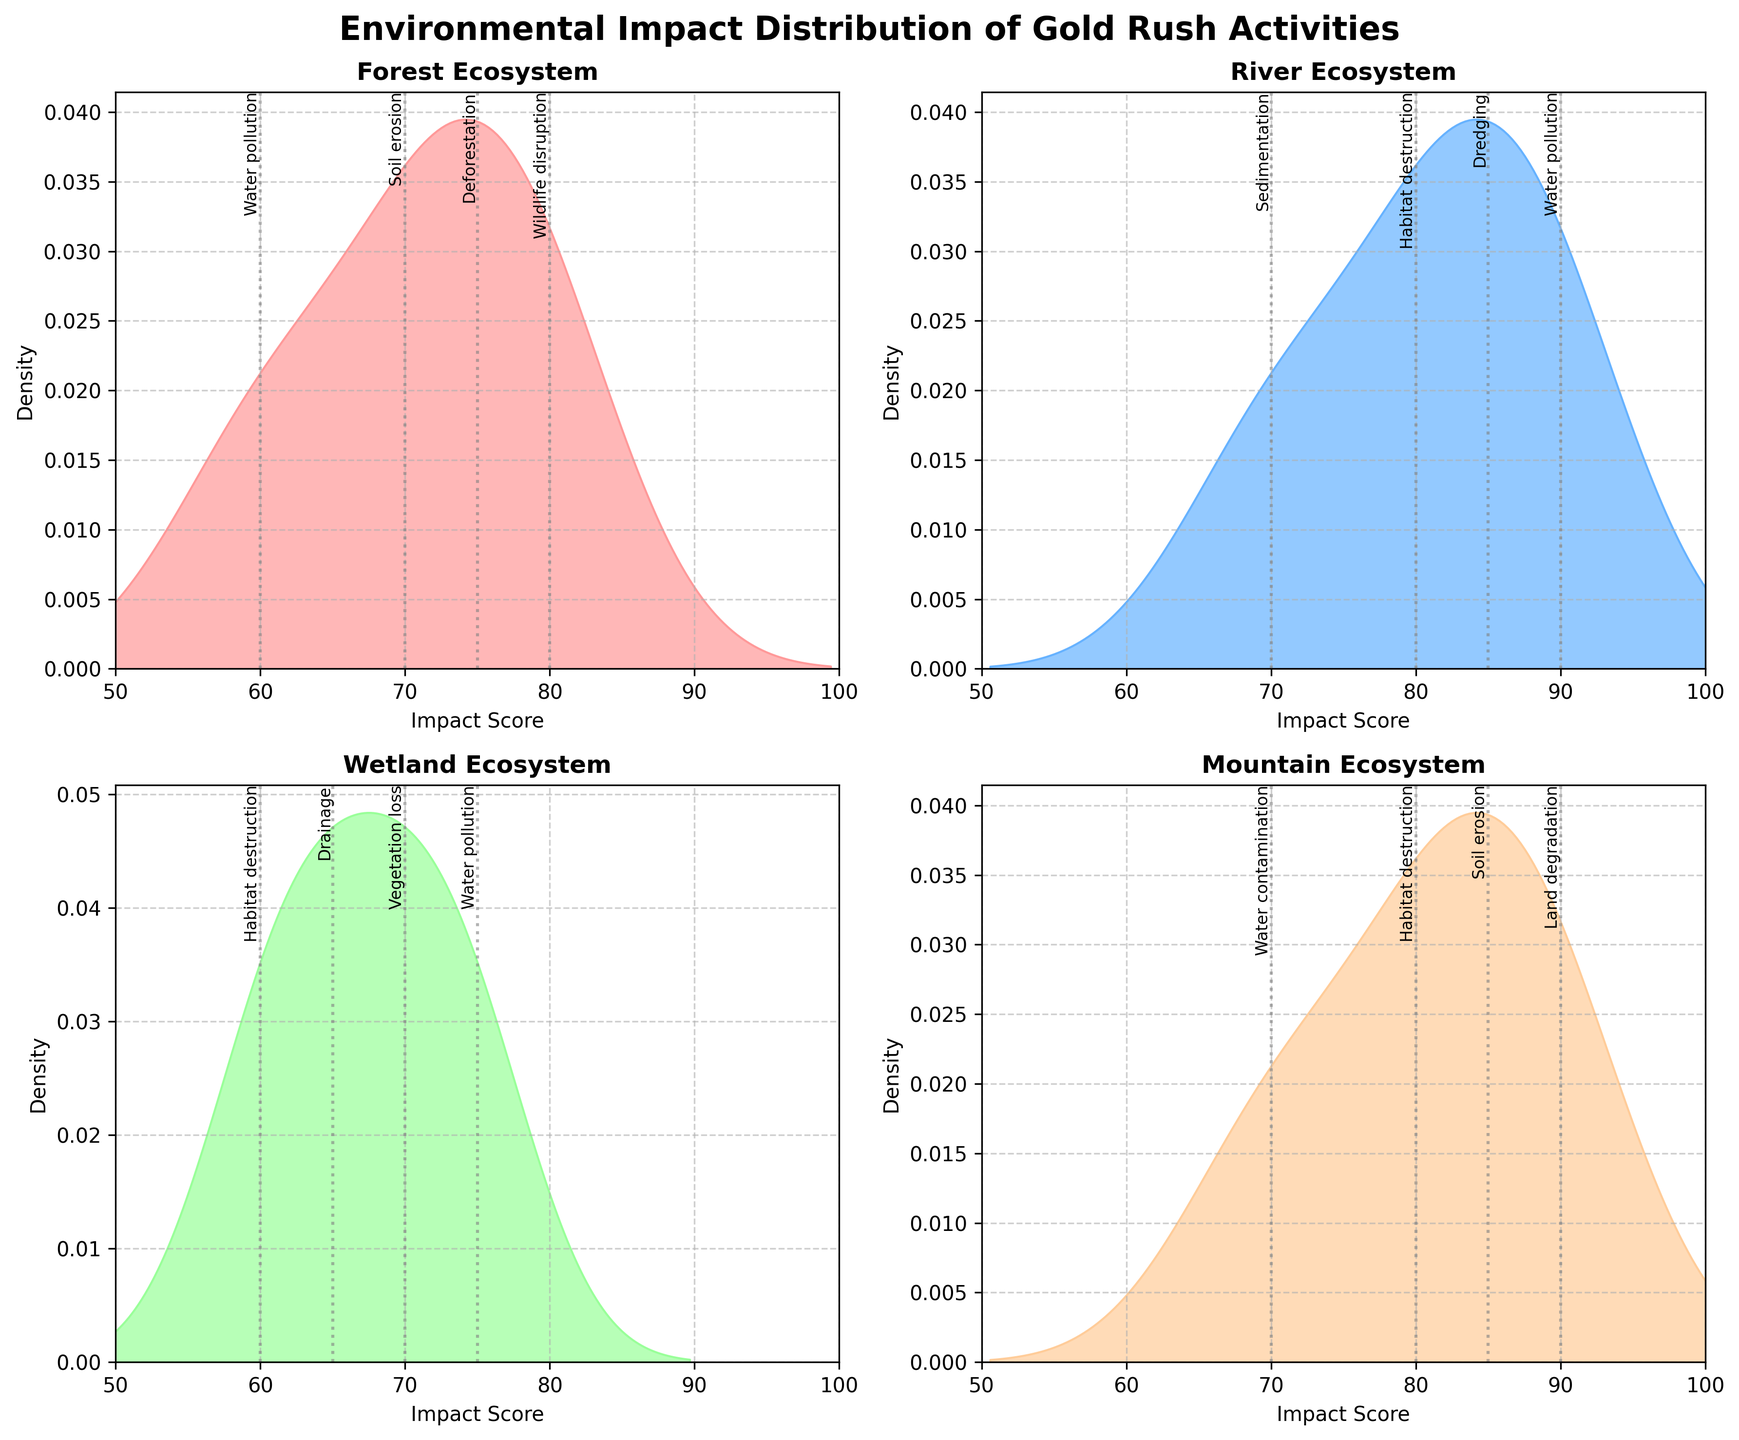What is the title of the figure? The title is shown at the top of the figure and reads: "Environmental Impact Distribution of Gold Rush Activities"
Answer: Environmental Impact Distribution of Gold Rush Activities Which ecosystem shows the highest density peak for the impact score? By examining the density peaks for each subplot, the River ecosystem shows the highest density peak.
Answer: River What is the range of impact scores displayed on the x-axis across all subplots? Observing the x-axes of all subplots, the range of impact scores displayed is from 50 to 100.
Answer: 50 to 100 Which activity has the highest impact score in the Mountain ecosystem? In the Mountain ecosystem subplot, the activity with the highest impact score is "Land degradation" at 90.
Answer: Land degradation Which ecosystem shows the most activities with an impact score of 70? Both the Forest and River ecosystems have activities with an impact score of 70 when checking the vertical gray lines and associated labels.
Answer: Forest and River How does the density curve of the Wetland ecosystem compare to the Mountain ecosystem in terms of peak value? Comparing the density curves, the Mountain ecosystem density peak is higher than the Wetland ecosystem's peak.
Answer: Mountain higher What is the impact score for "Water contamination" in the Mountain ecosystem? The activity "Water contamination" is marked with a vertical line at an impact score of 70 in the Mountain ecosystem subplot.
Answer: 70 Which ecosystem has the widest spread in impact scores? The River ecosystem has activities with impact scores ranging from 70 to 90, indicating the widest spread.
Answer: River Is there any activity with an impact score greater than 90? There are no vertical lines extending beyond the impact score of 90 in any subplot, indicating no activity has a score greater than 90.
Answer: No, there is none How many activities have an impact score of 85, and which ecosystems do they belong to? By identifying vertical lines at the score of 85, "Dredging" in the River ecosystem and "Soil erosion" in the Mountain ecosystem have an impact score of 85.
Answer: Two: River and Mountain 